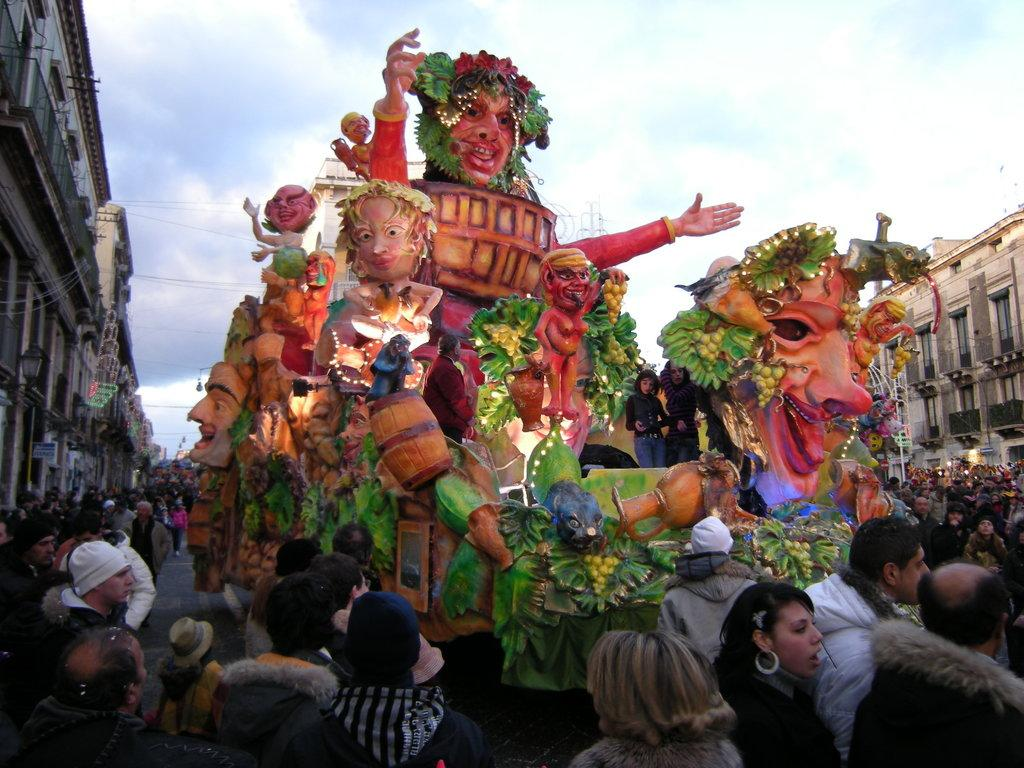What type of objects are in the image? There are statues in the image. Who or what else is present in the image? There are people and buildings in the image. What part of the natural environment is visible in the image? The sky is visible in the image. What type of rose is being held by the statue in the image? There is no rose present in the image; it features statues, people, and buildings. 